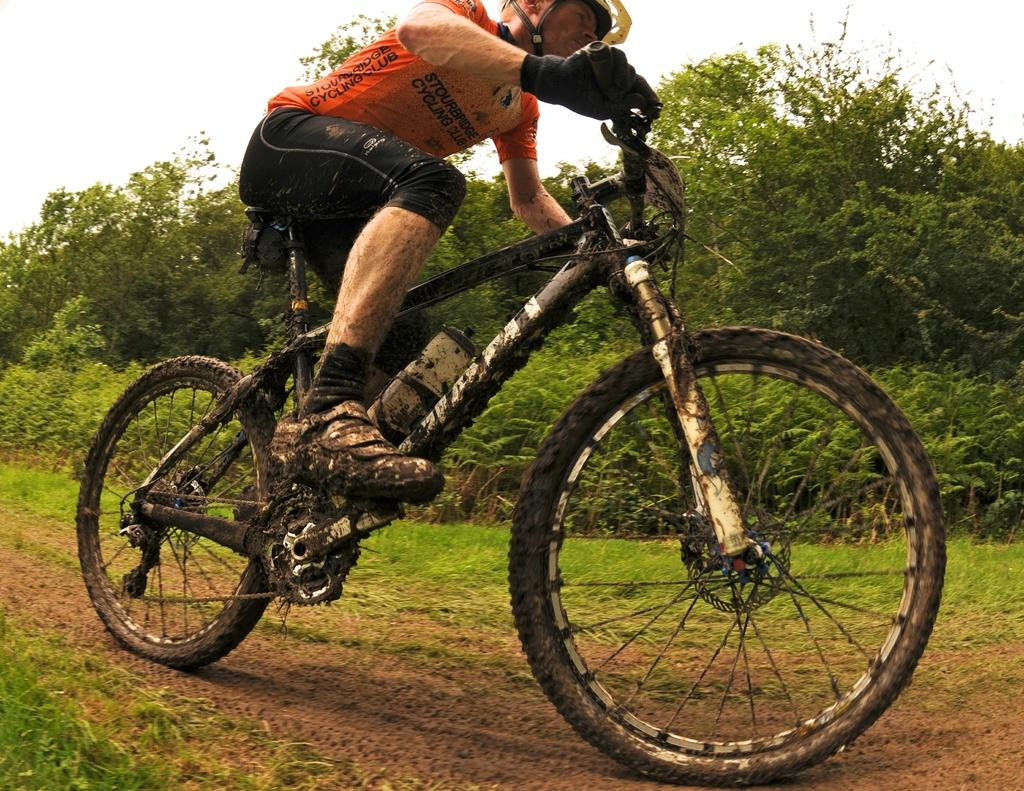Provide a one-sentence caption for the provided image. Person wearing an orange shirt which says "Stourbridge Cycling Club" riding a dirty bike. 